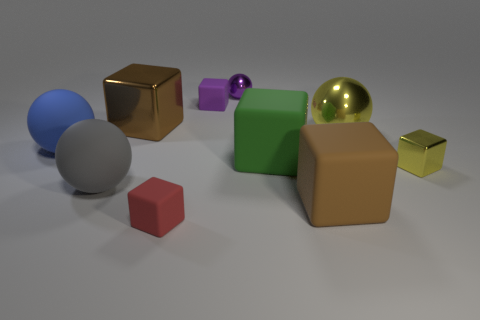What is the size of the brown cube that is made of the same material as the small yellow object?
Make the answer very short. Large. What shape is the big gray matte object?
Your answer should be very brief. Sphere. Are the yellow ball and the big brown object that is behind the large yellow thing made of the same material?
Your response must be concise. Yes. How many things are either blue rubber balls or brown things?
Ensure brevity in your answer.  3. Are there any big purple rubber spheres?
Your response must be concise. No. There is a small metal object behind the shiny block behind the big yellow sphere; what shape is it?
Give a very brief answer. Sphere. How many objects are brown blocks that are behind the tiny yellow block or big brown cubes that are to the left of the tiny metallic sphere?
Provide a short and direct response. 1. What material is the yellow ball that is the same size as the gray thing?
Offer a terse response. Metal. The tiny metallic sphere is what color?
Your response must be concise. Purple. The small cube that is in front of the green rubber block and behind the big gray object is made of what material?
Keep it short and to the point. Metal. 